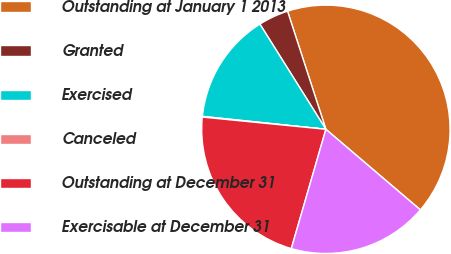Convert chart to OTSL. <chart><loc_0><loc_0><loc_500><loc_500><pie_chart><fcel>Outstanding at January 1 2013<fcel>Granted<fcel>Exercised<fcel>Canceled<fcel>Outstanding at December 31<fcel>Exercisable at December 31<nl><fcel>41.23%<fcel>3.92%<fcel>14.42%<fcel>0.09%<fcel>22.08%<fcel>18.25%<nl></chart> 